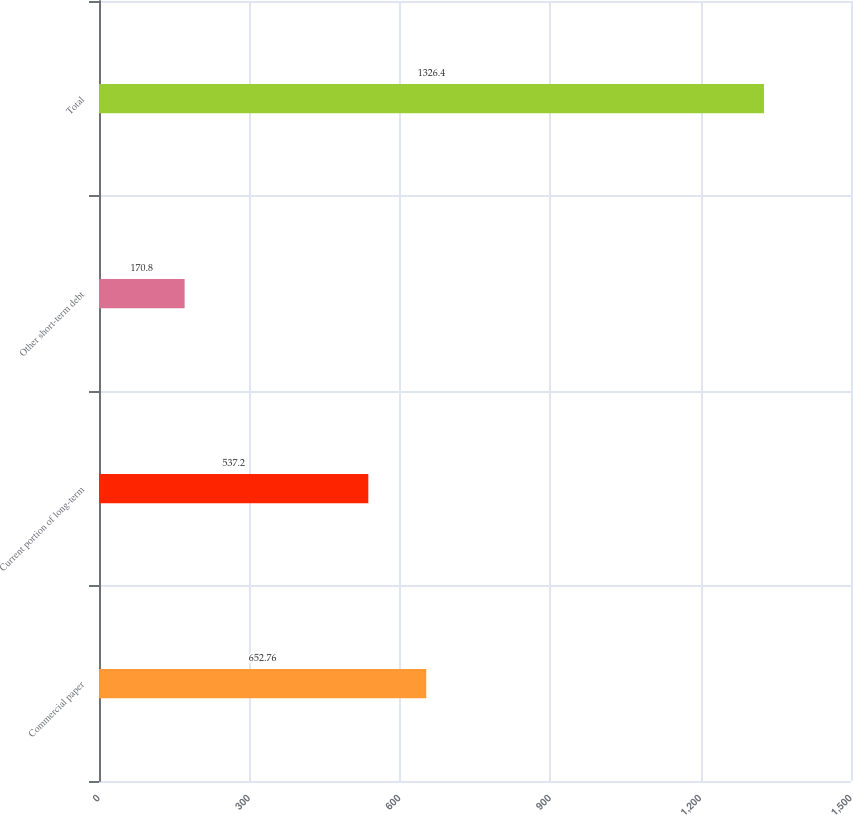<chart> <loc_0><loc_0><loc_500><loc_500><bar_chart><fcel>Commercial paper<fcel>Current portion of long-term<fcel>Other short-term debt<fcel>Total<nl><fcel>652.76<fcel>537.2<fcel>170.8<fcel>1326.4<nl></chart> 